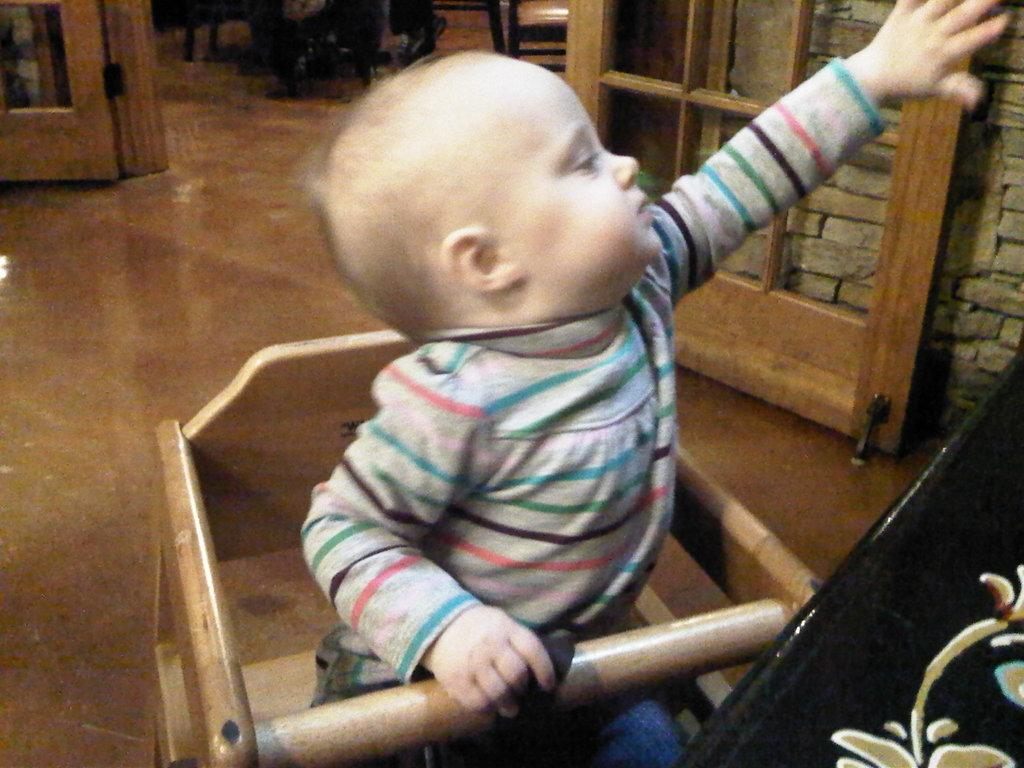Who is the main subject in the image? There is a boy in the image. What is the boy doing in the image? The boy is sitting in a chair. What can be seen behind the boy? There is a door visible in the image. What is the wall made of behind the door? There is a brick wall behind the door. How many clams are on the boy's plate during the feast in the image? There is no feast or clams present in the image; it features a boy sitting in a chair with a door and a brick wall behind it. 